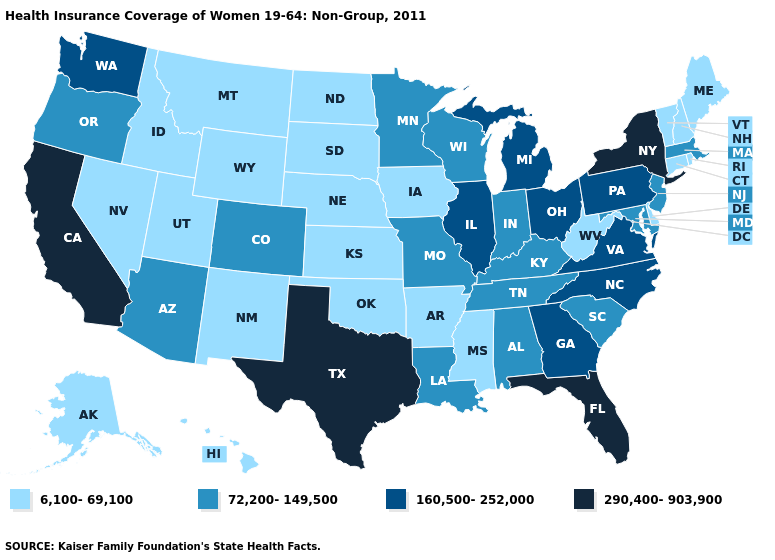Does Virginia have a higher value than Hawaii?
Answer briefly. Yes. Among the states that border Connecticut , does Rhode Island have the lowest value?
Short answer required. Yes. Among the states that border Georgia , which have the highest value?
Quick response, please. Florida. Name the states that have a value in the range 290,400-903,900?
Quick response, please. California, Florida, New York, Texas. What is the highest value in the USA?
Quick response, please. 290,400-903,900. Does Minnesota have a lower value than Iowa?
Short answer required. No. What is the highest value in states that border Arizona?
Keep it brief. 290,400-903,900. Does South Carolina have the same value as Maryland?
Quick response, please. Yes. Does Arkansas have the lowest value in the USA?
Write a very short answer. Yes. Does North Dakota have the highest value in the USA?
Answer briefly. No. Name the states that have a value in the range 6,100-69,100?
Be succinct. Alaska, Arkansas, Connecticut, Delaware, Hawaii, Idaho, Iowa, Kansas, Maine, Mississippi, Montana, Nebraska, Nevada, New Hampshire, New Mexico, North Dakota, Oklahoma, Rhode Island, South Dakota, Utah, Vermont, West Virginia, Wyoming. What is the value of Vermont?
Quick response, please. 6,100-69,100. Among the states that border Wyoming , which have the lowest value?
Quick response, please. Idaho, Montana, Nebraska, South Dakota, Utah. What is the highest value in the South ?
Be succinct. 290,400-903,900. How many symbols are there in the legend?
Be succinct. 4. 